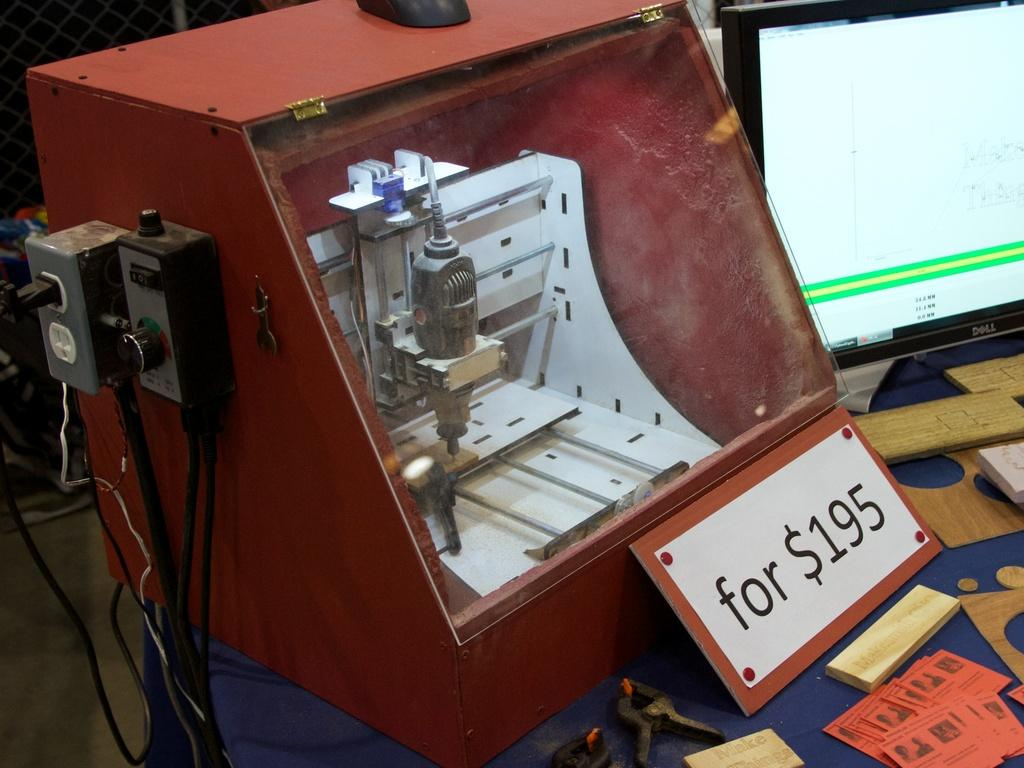<image>
Summarize the visual content of the image. 195 dollars is printed on the sign in front of this machine. 